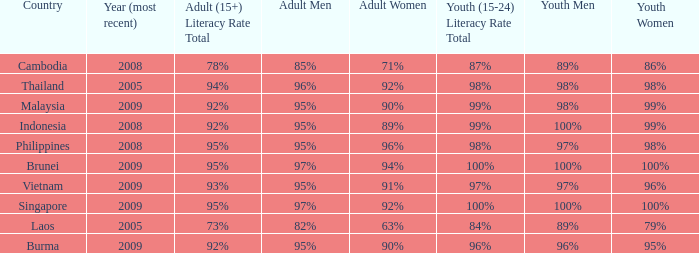Which country has a Youth (15-24) Literacy Rate Total of 100% and has an Adult Women Literacy rate of 92%? Singapore. 